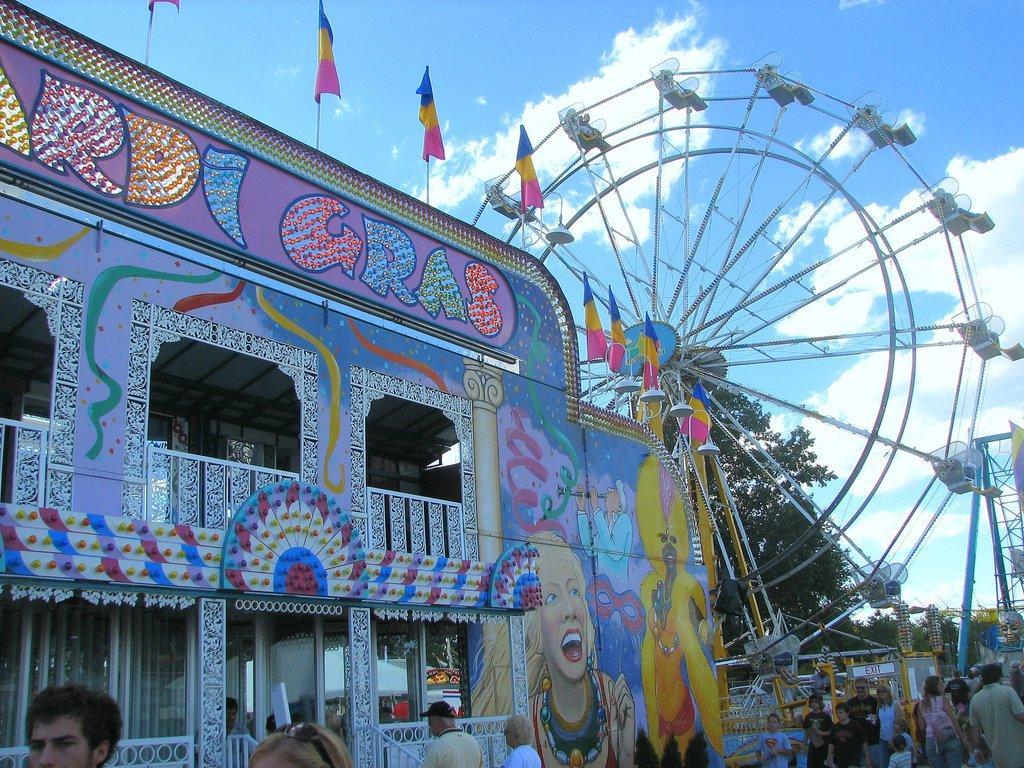Could you give a brief overview of what you see in this image? There are people and we can see building,fences and giant wheel,we can see painting on the wall and top of the building we can see flags with sticks. In the background we can see trees,rods and sky with clouds. 